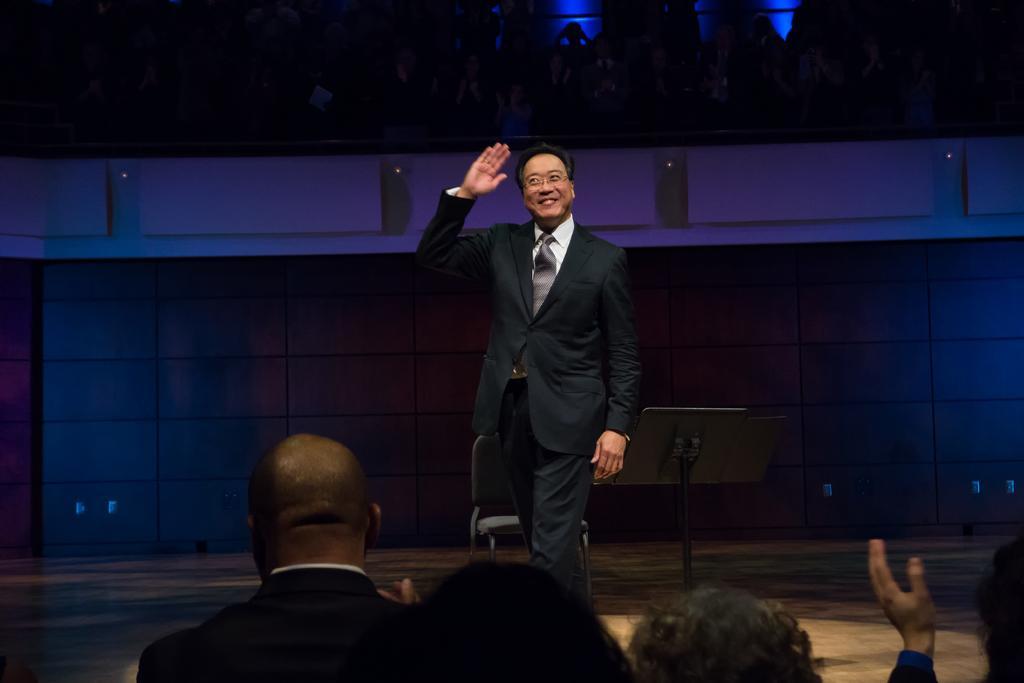Describe this image in one or two sentences. In this image we can see a person standing. Behind the person there is a chair, stand and a wall. At the top we can see a group of persons. At the bottom there are few persons. 